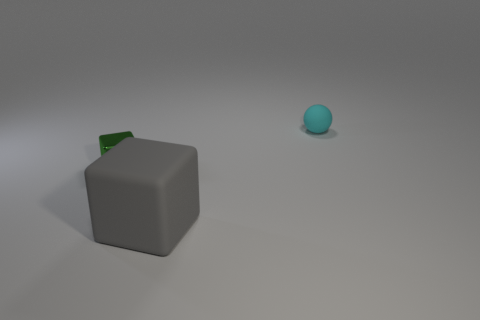Are there any small shiny blocks?
Your response must be concise. Yes. The cyan ball that is behind the matte object that is on the left side of the small object that is behind the small metal object is made of what material?
Your answer should be compact. Rubber. Are there fewer gray things on the left side of the large cube than small shiny objects?
Keep it short and to the point. Yes. What is the material of the green thing that is the same size as the cyan thing?
Keep it short and to the point. Metal. There is a thing that is right of the tiny shiny block and on the left side of the cyan rubber object; how big is it?
Your answer should be very brief. Large. What is the size of the other green object that is the same shape as the big thing?
Your answer should be compact. Small. How many things are either large green objects or gray matte cubes that are to the left of the small cyan matte ball?
Your answer should be compact. 1. The small matte thing is what shape?
Your response must be concise. Sphere. The matte object that is behind the object that is to the left of the large matte cube is what shape?
Ensure brevity in your answer.  Sphere. The ball that is the same material as the big object is what color?
Your response must be concise. Cyan. 